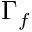Convert formula to latex. <formula><loc_0><loc_0><loc_500><loc_500>\Gamma _ { f }</formula> 